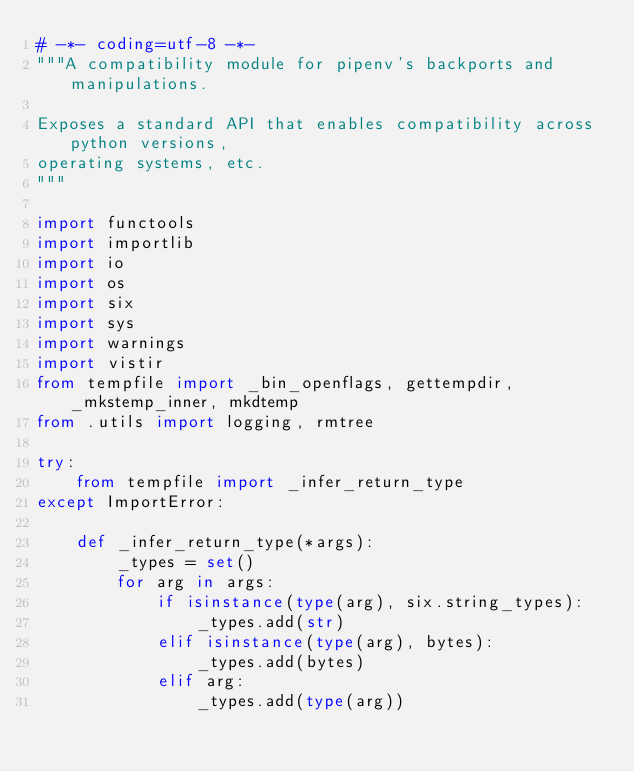Convert code to text. <code><loc_0><loc_0><loc_500><loc_500><_Python_># -*- coding=utf-8 -*-
"""A compatibility module for pipenv's backports and manipulations.

Exposes a standard API that enables compatibility across python versions,
operating systems, etc.
"""

import functools
import importlib
import io
import os
import six
import sys
import warnings
import vistir
from tempfile import _bin_openflags, gettempdir, _mkstemp_inner, mkdtemp
from .utils import logging, rmtree

try:
    from tempfile import _infer_return_type
except ImportError:

    def _infer_return_type(*args):
        _types = set()
        for arg in args:
            if isinstance(type(arg), six.string_types):
                _types.add(str)
            elif isinstance(type(arg), bytes):
                _types.add(bytes)
            elif arg:
                _types.add(type(arg))</code> 